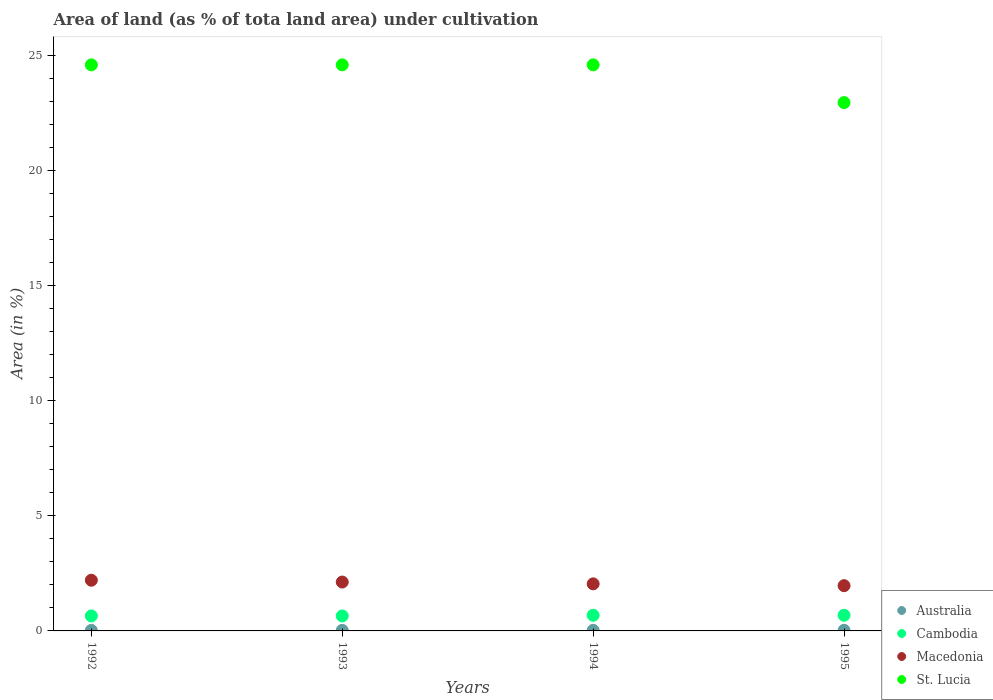Is the number of dotlines equal to the number of legend labels?
Offer a terse response. Yes. What is the percentage of land under cultivation in St. Lucia in 1993?
Provide a short and direct response. 24.59. Across all years, what is the maximum percentage of land under cultivation in St. Lucia?
Offer a very short reply. 24.59. Across all years, what is the minimum percentage of land under cultivation in Cambodia?
Your answer should be very brief. 0.65. What is the total percentage of land under cultivation in Cambodia in the graph?
Offer a very short reply. 2.66. What is the difference between the percentage of land under cultivation in St. Lucia in 1993 and that in 1995?
Your answer should be very brief. 1.64. What is the difference between the percentage of land under cultivation in Cambodia in 1993 and the percentage of land under cultivation in Australia in 1994?
Provide a short and direct response. 0.63. What is the average percentage of land under cultivation in Macedonia per year?
Your answer should be very brief. 2.08. In the year 1993, what is the difference between the percentage of land under cultivation in Macedonia and percentage of land under cultivation in St. Lucia?
Make the answer very short. -22.47. In how many years, is the percentage of land under cultivation in Australia greater than 10 %?
Keep it short and to the point. 0. What is the ratio of the percentage of land under cultivation in Australia in 1992 to that in 1995?
Give a very brief answer. 0.88. Is the percentage of land under cultivation in Macedonia in 1992 less than that in 1995?
Provide a short and direct response. No. What is the difference between the highest and the second highest percentage of land under cultivation in St. Lucia?
Offer a very short reply. 0. What is the difference between the highest and the lowest percentage of land under cultivation in Macedonia?
Provide a short and direct response. 0.24. In how many years, is the percentage of land under cultivation in Macedonia greater than the average percentage of land under cultivation in Macedonia taken over all years?
Make the answer very short. 2. Is the sum of the percentage of land under cultivation in Cambodia in 1992 and 1994 greater than the maximum percentage of land under cultivation in St. Lucia across all years?
Provide a short and direct response. No. Is it the case that in every year, the sum of the percentage of land under cultivation in Cambodia and percentage of land under cultivation in Australia  is greater than the sum of percentage of land under cultivation in St. Lucia and percentage of land under cultivation in Macedonia?
Offer a very short reply. No. Is it the case that in every year, the sum of the percentage of land under cultivation in Australia and percentage of land under cultivation in Cambodia  is greater than the percentage of land under cultivation in St. Lucia?
Your response must be concise. No. How many dotlines are there?
Make the answer very short. 4. How many years are there in the graph?
Give a very brief answer. 4. What is the difference between two consecutive major ticks on the Y-axis?
Give a very brief answer. 5. Where does the legend appear in the graph?
Provide a short and direct response. Bottom right. How are the legend labels stacked?
Offer a terse response. Vertical. What is the title of the graph?
Give a very brief answer. Area of land (as % of tota land area) under cultivation. What is the label or title of the X-axis?
Keep it short and to the point. Years. What is the label or title of the Y-axis?
Keep it short and to the point. Area (in %). What is the Area (in %) of Australia in 1992?
Offer a terse response. 0.02. What is the Area (in %) of Cambodia in 1992?
Your answer should be very brief. 0.65. What is the Area (in %) in Macedonia in 1992?
Your answer should be very brief. 2.2. What is the Area (in %) in St. Lucia in 1992?
Your response must be concise. 24.59. What is the Area (in %) of Australia in 1993?
Provide a succinct answer. 0.02. What is the Area (in %) of Cambodia in 1993?
Make the answer very short. 0.65. What is the Area (in %) of Macedonia in 1993?
Provide a short and direct response. 2.12. What is the Area (in %) of St. Lucia in 1993?
Ensure brevity in your answer.  24.59. What is the Area (in %) in Australia in 1994?
Offer a terse response. 0.03. What is the Area (in %) in Cambodia in 1994?
Your answer should be compact. 0.68. What is the Area (in %) of Macedonia in 1994?
Ensure brevity in your answer.  2.04. What is the Area (in %) in St. Lucia in 1994?
Give a very brief answer. 24.59. What is the Area (in %) in Australia in 1995?
Give a very brief answer. 0.03. What is the Area (in %) of Cambodia in 1995?
Ensure brevity in your answer.  0.68. What is the Area (in %) of Macedonia in 1995?
Offer a very short reply. 1.97. What is the Area (in %) in St. Lucia in 1995?
Provide a short and direct response. 22.95. Across all years, what is the maximum Area (in %) of Australia?
Your answer should be very brief. 0.03. Across all years, what is the maximum Area (in %) of Cambodia?
Your answer should be very brief. 0.68. Across all years, what is the maximum Area (in %) in Macedonia?
Offer a terse response. 2.2. Across all years, what is the maximum Area (in %) of St. Lucia?
Give a very brief answer. 24.59. Across all years, what is the minimum Area (in %) in Australia?
Offer a very short reply. 0.02. Across all years, what is the minimum Area (in %) in Cambodia?
Keep it short and to the point. 0.65. Across all years, what is the minimum Area (in %) in Macedonia?
Offer a terse response. 1.97. Across all years, what is the minimum Area (in %) in St. Lucia?
Provide a short and direct response. 22.95. What is the total Area (in %) of Australia in the graph?
Your response must be concise. 0.1. What is the total Area (in %) in Cambodia in the graph?
Offer a very short reply. 2.66. What is the total Area (in %) in Macedonia in the graph?
Your response must be concise. 8.34. What is the total Area (in %) of St. Lucia in the graph?
Make the answer very short. 96.72. What is the difference between the Area (in %) of Australia in 1992 and that in 1993?
Your response must be concise. -0. What is the difference between the Area (in %) of Cambodia in 1992 and that in 1993?
Make the answer very short. 0. What is the difference between the Area (in %) of Macedonia in 1992 and that in 1993?
Your response must be concise. 0.08. What is the difference between the Area (in %) of Australia in 1992 and that in 1994?
Your answer should be very brief. -0. What is the difference between the Area (in %) of Cambodia in 1992 and that in 1994?
Offer a terse response. -0.03. What is the difference between the Area (in %) in Macedonia in 1992 and that in 1994?
Your answer should be compact. 0.16. What is the difference between the Area (in %) of St. Lucia in 1992 and that in 1994?
Offer a terse response. 0. What is the difference between the Area (in %) of Australia in 1992 and that in 1995?
Offer a terse response. -0. What is the difference between the Area (in %) of Cambodia in 1992 and that in 1995?
Provide a succinct answer. -0.03. What is the difference between the Area (in %) in Macedonia in 1992 and that in 1995?
Make the answer very short. 0.24. What is the difference between the Area (in %) in St. Lucia in 1992 and that in 1995?
Give a very brief answer. 1.64. What is the difference between the Area (in %) in Australia in 1993 and that in 1994?
Provide a short and direct response. -0. What is the difference between the Area (in %) in Cambodia in 1993 and that in 1994?
Your response must be concise. -0.03. What is the difference between the Area (in %) in Macedonia in 1993 and that in 1994?
Offer a terse response. 0.08. What is the difference between the Area (in %) in Australia in 1993 and that in 1995?
Your response must be concise. -0. What is the difference between the Area (in %) of Cambodia in 1993 and that in 1995?
Your response must be concise. -0.03. What is the difference between the Area (in %) of Macedonia in 1993 and that in 1995?
Ensure brevity in your answer.  0.16. What is the difference between the Area (in %) of St. Lucia in 1993 and that in 1995?
Provide a succinct answer. 1.64. What is the difference between the Area (in %) in Australia in 1994 and that in 1995?
Offer a terse response. -0. What is the difference between the Area (in %) of Macedonia in 1994 and that in 1995?
Offer a very short reply. 0.08. What is the difference between the Area (in %) in St. Lucia in 1994 and that in 1995?
Ensure brevity in your answer.  1.64. What is the difference between the Area (in %) of Australia in 1992 and the Area (in %) of Cambodia in 1993?
Offer a very short reply. -0.63. What is the difference between the Area (in %) in Australia in 1992 and the Area (in %) in Macedonia in 1993?
Your response must be concise. -2.1. What is the difference between the Area (in %) of Australia in 1992 and the Area (in %) of St. Lucia in 1993?
Ensure brevity in your answer.  -24.57. What is the difference between the Area (in %) of Cambodia in 1992 and the Area (in %) of Macedonia in 1993?
Offer a very short reply. -1.47. What is the difference between the Area (in %) in Cambodia in 1992 and the Area (in %) in St. Lucia in 1993?
Your answer should be very brief. -23.94. What is the difference between the Area (in %) in Macedonia in 1992 and the Area (in %) in St. Lucia in 1993?
Your answer should be very brief. -22.39. What is the difference between the Area (in %) of Australia in 1992 and the Area (in %) of Cambodia in 1994?
Ensure brevity in your answer.  -0.66. What is the difference between the Area (in %) in Australia in 1992 and the Area (in %) in Macedonia in 1994?
Your response must be concise. -2.02. What is the difference between the Area (in %) of Australia in 1992 and the Area (in %) of St. Lucia in 1994?
Make the answer very short. -24.57. What is the difference between the Area (in %) in Cambodia in 1992 and the Area (in %) in Macedonia in 1994?
Offer a terse response. -1.39. What is the difference between the Area (in %) in Cambodia in 1992 and the Area (in %) in St. Lucia in 1994?
Provide a short and direct response. -23.94. What is the difference between the Area (in %) in Macedonia in 1992 and the Area (in %) in St. Lucia in 1994?
Provide a succinct answer. -22.39. What is the difference between the Area (in %) of Australia in 1992 and the Area (in %) of Cambodia in 1995?
Your response must be concise. -0.66. What is the difference between the Area (in %) of Australia in 1992 and the Area (in %) of Macedonia in 1995?
Your response must be concise. -1.94. What is the difference between the Area (in %) of Australia in 1992 and the Area (in %) of St. Lucia in 1995?
Give a very brief answer. -22.93. What is the difference between the Area (in %) of Cambodia in 1992 and the Area (in %) of Macedonia in 1995?
Provide a short and direct response. -1.31. What is the difference between the Area (in %) of Cambodia in 1992 and the Area (in %) of St. Lucia in 1995?
Ensure brevity in your answer.  -22.3. What is the difference between the Area (in %) of Macedonia in 1992 and the Area (in %) of St. Lucia in 1995?
Provide a succinct answer. -20.75. What is the difference between the Area (in %) of Australia in 1993 and the Area (in %) of Cambodia in 1994?
Offer a very short reply. -0.66. What is the difference between the Area (in %) in Australia in 1993 and the Area (in %) in Macedonia in 1994?
Your answer should be very brief. -2.02. What is the difference between the Area (in %) of Australia in 1993 and the Area (in %) of St. Lucia in 1994?
Offer a terse response. -24.57. What is the difference between the Area (in %) of Cambodia in 1993 and the Area (in %) of Macedonia in 1994?
Give a very brief answer. -1.39. What is the difference between the Area (in %) of Cambodia in 1993 and the Area (in %) of St. Lucia in 1994?
Your answer should be very brief. -23.94. What is the difference between the Area (in %) in Macedonia in 1993 and the Area (in %) in St. Lucia in 1994?
Offer a very short reply. -22.47. What is the difference between the Area (in %) in Australia in 1993 and the Area (in %) in Cambodia in 1995?
Keep it short and to the point. -0.66. What is the difference between the Area (in %) of Australia in 1993 and the Area (in %) of Macedonia in 1995?
Make the answer very short. -1.94. What is the difference between the Area (in %) in Australia in 1993 and the Area (in %) in St. Lucia in 1995?
Your response must be concise. -22.93. What is the difference between the Area (in %) in Cambodia in 1993 and the Area (in %) in Macedonia in 1995?
Offer a very short reply. -1.31. What is the difference between the Area (in %) of Cambodia in 1993 and the Area (in %) of St. Lucia in 1995?
Offer a terse response. -22.3. What is the difference between the Area (in %) of Macedonia in 1993 and the Area (in %) of St. Lucia in 1995?
Give a very brief answer. -20.83. What is the difference between the Area (in %) in Australia in 1994 and the Area (in %) in Cambodia in 1995?
Give a very brief answer. -0.65. What is the difference between the Area (in %) of Australia in 1994 and the Area (in %) of Macedonia in 1995?
Provide a short and direct response. -1.94. What is the difference between the Area (in %) in Australia in 1994 and the Area (in %) in St. Lucia in 1995?
Provide a succinct answer. -22.92. What is the difference between the Area (in %) in Cambodia in 1994 and the Area (in %) in Macedonia in 1995?
Give a very brief answer. -1.29. What is the difference between the Area (in %) of Cambodia in 1994 and the Area (in %) of St. Lucia in 1995?
Your answer should be compact. -22.27. What is the difference between the Area (in %) of Macedonia in 1994 and the Area (in %) of St. Lucia in 1995?
Offer a terse response. -20.91. What is the average Area (in %) of Australia per year?
Ensure brevity in your answer.  0.03. What is the average Area (in %) in Cambodia per year?
Keep it short and to the point. 0.67. What is the average Area (in %) in Macedonia per year?
Give a very brief answer. 2.08. What is the average Area (in %) of St. Lucia per year?
Your response must be concise. 24.18. In the year 1992, what is the difference between the Area (in %) of Australia and Area (in %) of Cambodia?
Give a very brief answer. -0.63. In the year 1992, what is the difference between the Area (in %) of Australia and Area (in %) of Macedonia?
Your response must be concise. -2.18. In the year 1992, what is the difference between the Area (in %) in Australia and Area (in %) in St. Lucia?
Keep it short and to the point. -24.57. In the year 1992, what is the difference between the Area (in %) of Cambodia and Area (in %) of Macedonia?
Give a very brief answer. -1.55. In the year 1992, what is the difference between the Area (in %) of Cambodia and Area (in %) of St. Lucia?
Give a very brief answer. -23.94. In the year 1992, what is the difference between the Area (in %) in Macedonia and Area (in %) in St. Lucia?
Give a very brief answer. -22.39. In the year 1993, what is the difference between the Area (in %) in Australia and Area (in %) in Cambodia?
Keep it short and to the point. -0.63. In the year 1993, what is the difference between the Area (in %) in Australia and Area (in %) in Macedonia?
Your response must be concise. -2.1. In the year 1993, what is the difference between the Area (in %) in Australia and Area (in %) in St. Lucia?
Offer a very short reply. -24.57. In the year 1993, what is the difference between the Area (in %) of Cambodia and Area (in %) of Macedonia?
Provide a short and direct response. -1.47. In the year 1993, what is the difference between the Area (in %) in Cambodia and Area (in %) in St. Lucia?
Offer a very short reply. -23.94. In the year 1993, what is the difference between the Area (in %) in Macedonia and Area (in %) in St. Lucia?
Ensure brevity in your answer.  -22.47. In the year 1994, what is the difference between the Area (in %) in Australia and Area (in %) in Cambodia?
Offer a very short reply. -0.65. In the year 1994, what is the difference between the Area (in %) in Australia and Area (in %) in Macedonia?
Offer a terse response. -2.02. In the year 1994, what is the difference between the Area (in %) of Australia and Area (in %) of St. Lucia?
Give a very brief answer. -24.56. In the year 1994, what is the difference between the Area (in %) of Cambodia and Area (in %) of Macedonia?
Provide a short and direct response. -1.36. In the year 1994, what is the difference between the Area (in %) in Cambodia and Area (in %) in St. Lucia?
Keep it short and to the point. -23.91. In the year 1994, what is the difference between the Area (in %) in Macedonia and Area (in %) in St. Lucia?
Keep it short and to the point. -22.55. In the year 1995, what is the difference between the Area (in %) of Australia and Area (in %) of Cambodia?
Keep it short and to the point. -0.65. In the year 1995, what is the difference between the Area (in %) in Australia and Area (in %) in Macedonia?
Offer a very short reply. -1.94. In the year 1995, what is the difference between the Area (in %) in Australia and Area (in %) in St. Lucia?
Offer a very short reply. -22.92. In the year 1995, what is the difference between the Area (in %) in Cambodia and Area (in %) in Macedonia?
Your response must be concise. -1.29. In the year 1995, what is the difference between the Area (in %) in Cambodia and Area (in %) in St. Lucia?
Keep it short and to the point. -22.27. In the year 1995, what is the difference between the Area (in %) of Macedonia and Area (in %) of St. Lucia?
Offer a very short reply. -20.98. What is the ratio of the Area (in %) of Australia in 1992 to that in 1993?
Offer a very short reply. 0.96. What is the ratio of the Area (in %) of Cambodia in 1992 to that in 1993?
Your answer should be compact. 1. What is the ratio of the Area (in %) of Macedonia in 1992 to that in 1993?
Offer a very short reply. 1.04. What is the ratio of the Area (in %) in Australia in 1992 to that in 1994?
Your answer should be very brief. 0.89. What is the ratio of the Area (in %) of Cambodia in 1992 to that in 1994?
Provide a succinct answer. 0.96. What is the ratio of the Area (in %) of Macedonia in 1992 to that in 1994?
Make the answer very short. 1.08. What is the ratio of the Area (in %) in Australia in 1992 to that in 1995?
Provide a short and direct response. 0.88. What is the ratio of the Area (in %) of Cambodia in 1992 to that in 1995?
Offer a terse response. 0.96. What is the ratio of the Area (in %) in Macedonia in 1992 to that in 1995?
Your response must be concise. 1.12. What is the ratio of the Area (in %) of St. Lucia in 1992 to that in 1995?
Provide a short and direct response. 1.07. What is the ratio of the Area (in %) of Australia in 1993 to that in 1994?
Ensure brevity in your answer.  0.93. What is the ratio of the Area (in %) of St. Lucia in 1993 to that in 1994?
Offer a terse response. 1. What is the ratio of the Area (in %) in Australia in 1993 to that in 1995?
Offer a very short reply. 0.92. What is the ratio of the Area (in %) in Cambodia in 1993 to that in 1995?
Give a very brief answer. 0.96. What is the ratio of the Area (in %) in Macedonia in 1993 to that in 1995?
Your answer should be compact. 1.08. What is the ratio of the Area (in %) in St. Lucia in 1993 to that in 1995?
Your answer should be compact. 1.07. What is the ratio of the Area (in %) of Australia in 1994 to that in 1995?
Your response must be concise. 0.99. What is the ratio of the Area (in %) in Cambodia in 1994 to that in 1995?
Provide a short and direct response. 1. What is the ratio of the Area (in %) of St. Lucia in 1994 to that in 1995?
Offer a very short reply. 1.07. What is the difference between the highest and the second highest Area (in %) in Macedonia?
Your answer should be very brief. 0.08. What is the difference between the highest and the lowest Area (in %) of Australia?
Make the answer very short. 0. What is the difference between the highest and the lowest Area (in %) of Cambodia?
Your answer should be very brief. 0.03. What is the difference between the highest and the lowest Area (in %) in Macedonia?
Offer a very short reply. 0.24. What is the difference between the highest and the lowest Area (in %) of St. Lucia?
Provide a short and direct response. 1.64. 